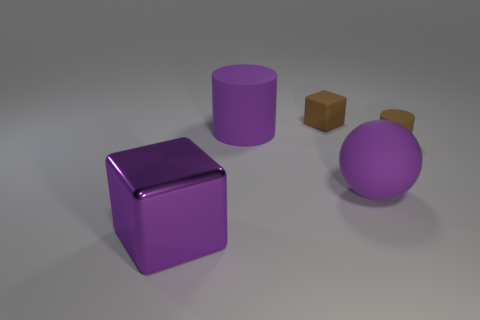How would you describe the arrangement and composition of the shapes in this image? The shapes are arranged with a sense of balance and simplicity. The arrangement features a purple cube and cylinder, and a sphere on the right, with a small brown cube resting beside the sphere. The composition uses a soft, neutral background that accentuates the colors and reflective properties of the shapes. 